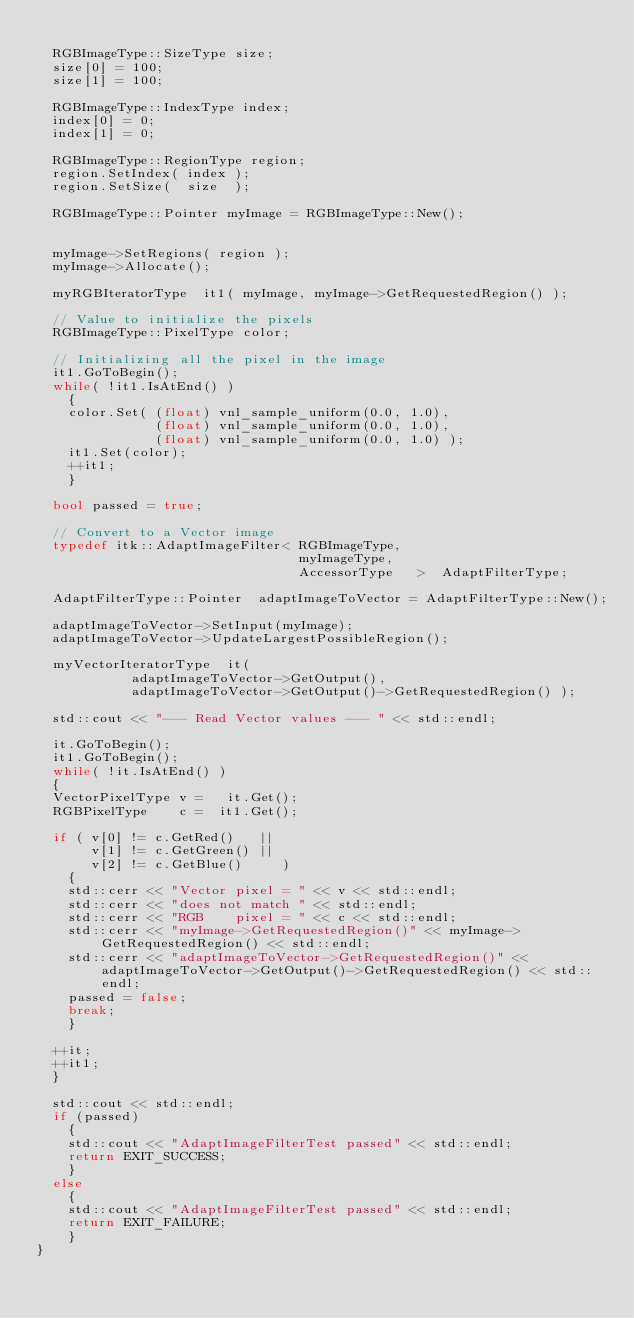Convert code to text. <code><loc_0><loc_0><loc_500><loc_500><_C++_>
  RGBImageType::SizeType size;
  size[0] = 100;
  size[1] = 100;

  RGBImageType::IndexType index;
  index[0] = 0;
  index[1] = 0;

  RGBImageType::RegionType region;
  region.SetIndex( index );
  region.SetSize(  size  );

  RGBImageType::Pointer myImage = RGBImageType::New();


  myImage->SetRegions( region );
  myImage->Allocate();

  myRGBIteratorType  it1( myImage, myImage->GetRequestedRegion() );

  // Value to initialize the pixels
  RGBImageType::PixelType color;

  // Initializing all the pixel in the image
  it1.GoToBegin();
  while( !it1.IsAtEnd() )
    {
    color.Set( (float) vnl_sample_uniform(0.0, 1.0),
               (float) vnl_sample_uniform(0.0, 1.0),
               (float) vnl_sample_uniform(0.0, 1.0) );
    it1.Set(color);
    ++it1;
    }

  bool passed = true;

  // Convert to a Vector image
  typedef itk::AdaptImageFilter< RGBImageType,
                                 myImageType,
                                 AccessorType   >  AdaptFilterType;

  AdaptFilterType::Pointer  adaptImageToVector = AdaptFilterType::New();

  adaptImageToVector->SetInput(myImage);
  adaptImageToVector->UpdateLargestPossibleRegion();

  myVectorIteratorType  it(
            adaptImageToVector->GetOutput(),
            adaptImageToVector->GetOutput()->GetRequestedRegion() );

  std::cout << "--- Read Vector values --- " << std::endl;

  it.GoToBegin();
  it1.GoToBegin();
  while( !it.IsAtEnd() )
  {
  VectorPixelType v =   it.Get();
  RGBPixelType    c =  it1.Get();

  if ( v[0] != c.GetRed()   ||
       v[1] != c.GetGreen() ||
       v[2] != c.GetBlue()     )
    {
    std::cerr << "Vector pixel = " << v << std::endl;
    std::cerr << "does not match " << std::endl;
    std::cerr << "RGB    pixel = " << c << std::endl;
    std::cerr << "myImage->GetRequestedRegion()" << myImage->GetRequestedRegion() << std::endl;
    std::cerr << "adaptImageToVector->GetRequestedRegion()" << adaptImageToVector->GetOutput()->GetRequestedRegion() << std::endl;
    passed = false;
    break;
    }

  ++it;
  ++it1;
  }

  std::cout << std::endl;
  if (passed)
    {
    std::cout << "AdaptImageFilterTest passed" << std::endl;
    return EXIT_SUCCESS;
    }
  else
    {
    std::cout << "AdaptImageFilterTest passed" << std::endl;
    return EXIT_FAILURE;
    }
}



</code> 